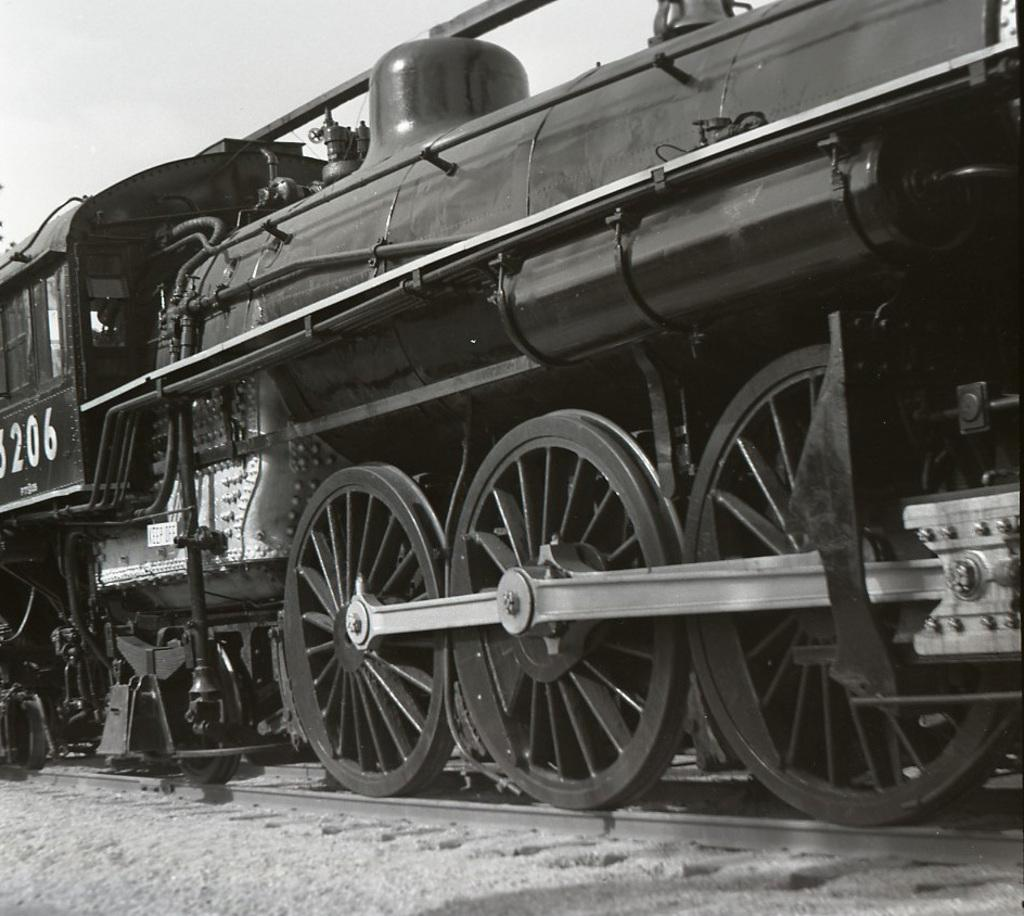What is the color scheme of the image? A: The image is black and white. What is the main subject of the image? There is a train in the image. Where is the train located in the image? The train is on a railway track. What type of insect can be seen playing an instrument on the train in the image? There is no insect or instrument present on the train in the image; it is a black and white image of a train on a railway track. 